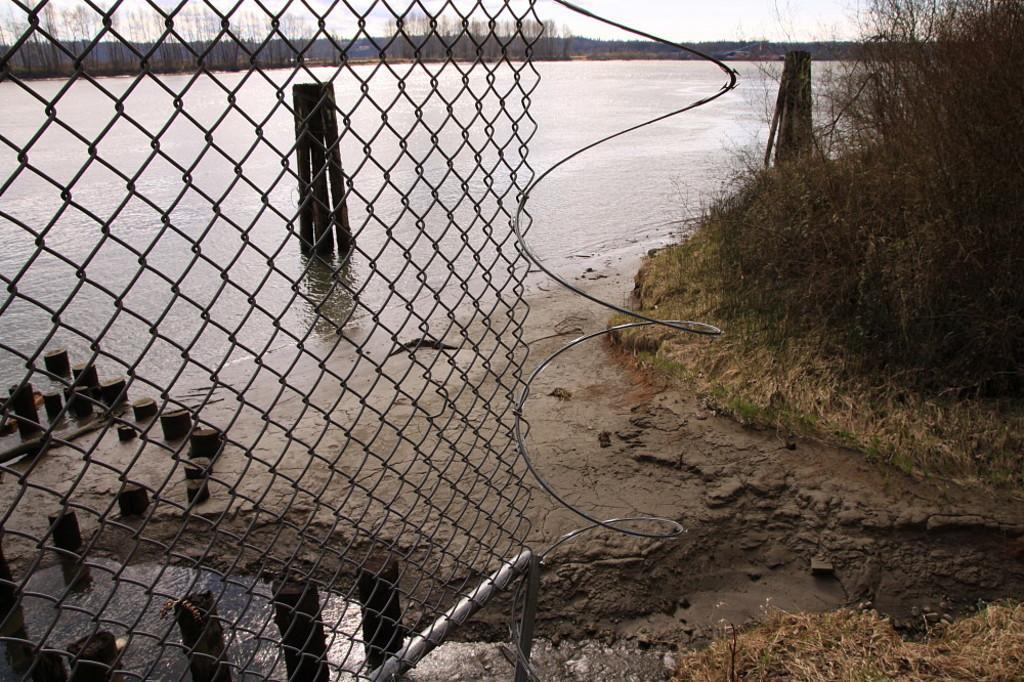In one or two sentences, can you explain what this image depicts? In this picture I can see water and I can see metal fence, trees and a cloudy sky. 